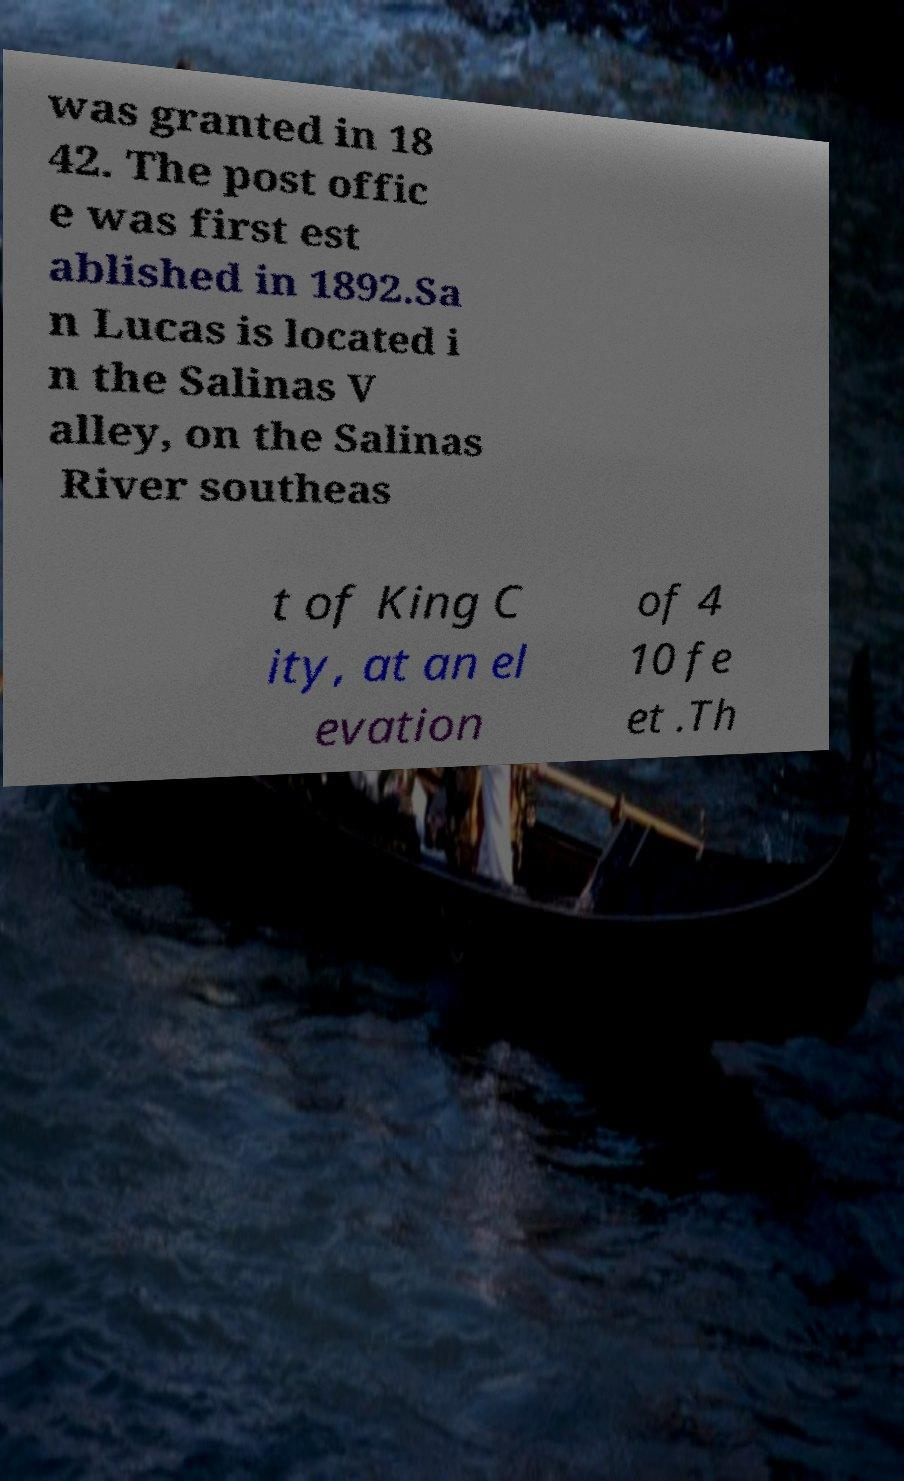Can you read and provide the text displayed in the image?This photo seems to have some interesting text. Can you extract and type it out for me? was granted in 18 42. The post offic e was first est ablished in 1892.Sa n Lucas is located i n the Salinas V alley, on the Salinas River southeas t of King C ity, at an el evation of 4 10 fe et .Th 